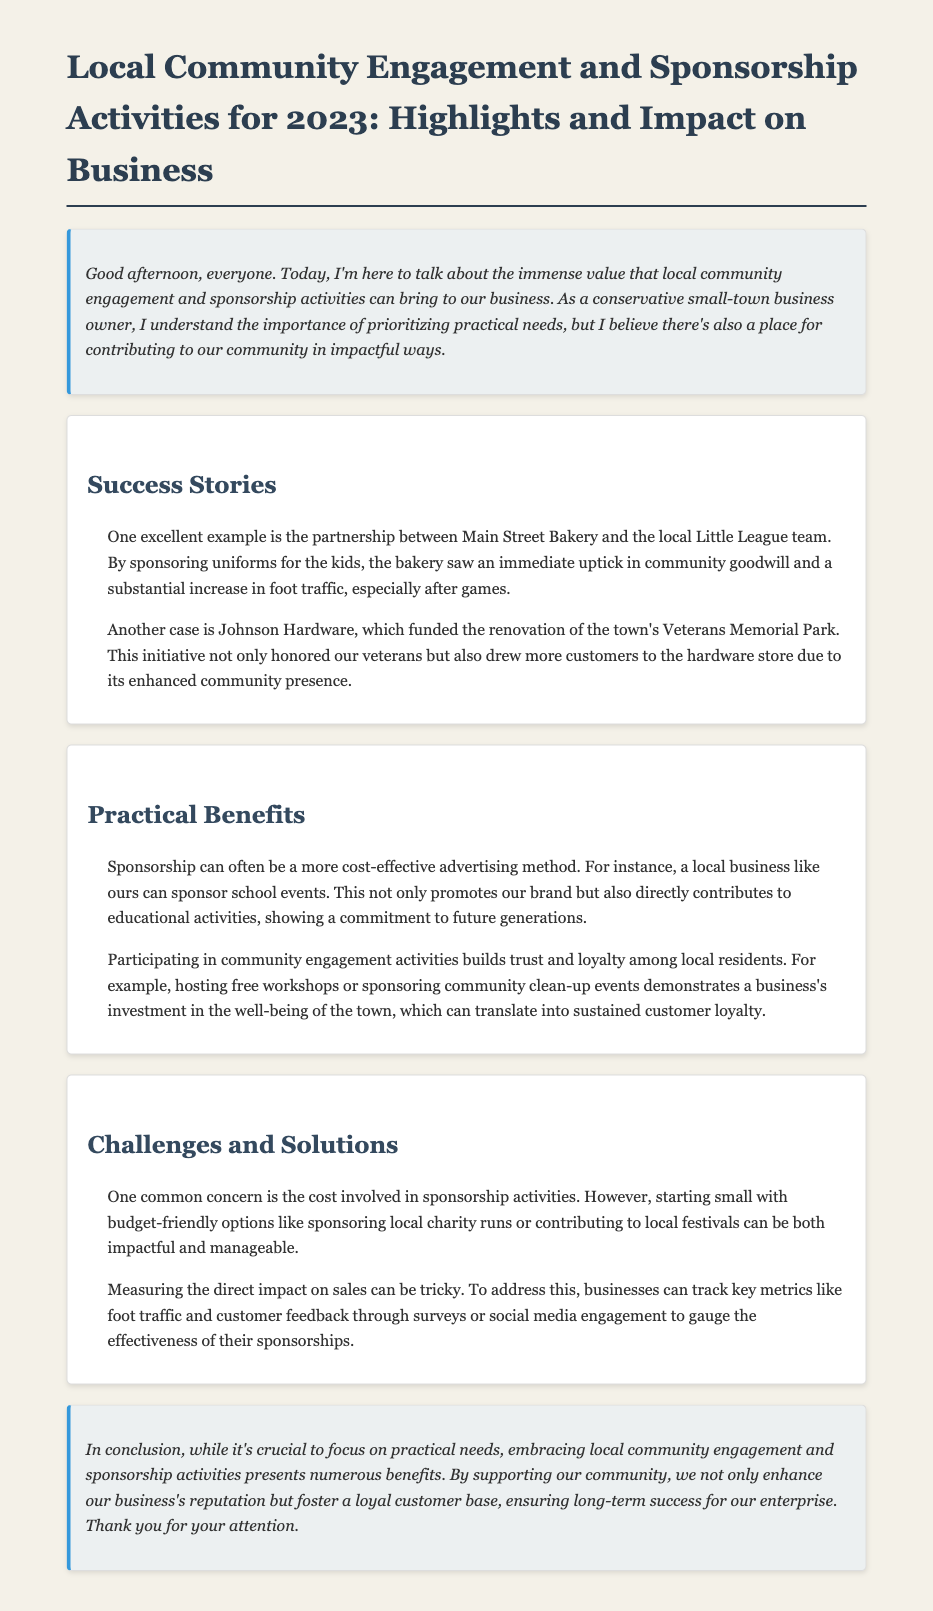What is the name of the bakery mentioned? The document references the partnership with Main Street Bakery, which sponsored the local Little League team.
Answer: Main Street Bakery What did Johnson Hardware fund? The transcript mentions that Johnson Hardware funded the renovation of the town's Veterans Memorial Park.
Answer: Renovation of the town's Veterans Memorial Park What is one of the practical benefits of sponsorship mentioned? The document states that sponsorship can be a more cost-effective advertising method, particularly for sponsoring school events.
Answer: Cost-effective advertising What is a challenge businesses face with sponsorship activities? The document notes that a common concern is the cost involved in sponsorship activities.
Answer: Cost What metrics can businesses track to gauge sponsorship effectiveness? The document suggests businesses can track foot traffic and customer feedback to measure the direct impact of sponsorships.
Answer: Foot traffic and customer feedback How does community engagement affect customer loyalty? The document asserts that participating in community engagement activities builds trust and loyalty among local residents.
Answer: Trust and loyalty What type of event can businesses start sponsoring to engage with the community? The transcript recommends starting with budget-friendly options like sponsoring local charity runs or contributing to local festivals.
Answer: Local charity runs What is the overall conclusion of the document regarding community engagement? The conclusion emphasizes that while focusing on practical needs is essential, community engagement also enhances business reputation and customer loyalty.
Answer: Enhances business reputation and customer loyalty 